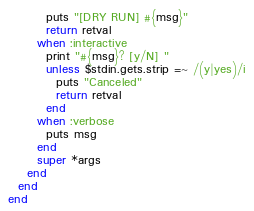<code> <loc_0><loc_0><loc_500><loc_500><_Ruby_>        puts "[DRY RUN] #{msg}"
        return retval
      when :interactive
        print "#{msg}? [y/N] "
        unless $stdin.gets.strip =~ /(y|yes)/i
          puts "Canceled"
          return retval
        end
      when :verbose
        puts msg
      end
      super *args
    end
  end
end
</code> 